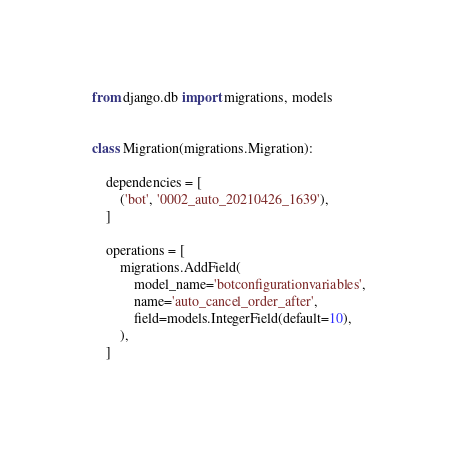<code> <loc_0><loc_0><loc_500><loc_500><_Python_>from django.db import migrations, models


class Migration(migrations.Migration):

    dependencies = [
        ('bot', '0002_auto_20210426_1639'),
    ]

    operations = [
        migrations.AddField(
            model_name='botconfigurationvariables',
            name='auto_cancel_order_after',
            field=models.IntegerField(default=10),
        ),
    ]
</code> 